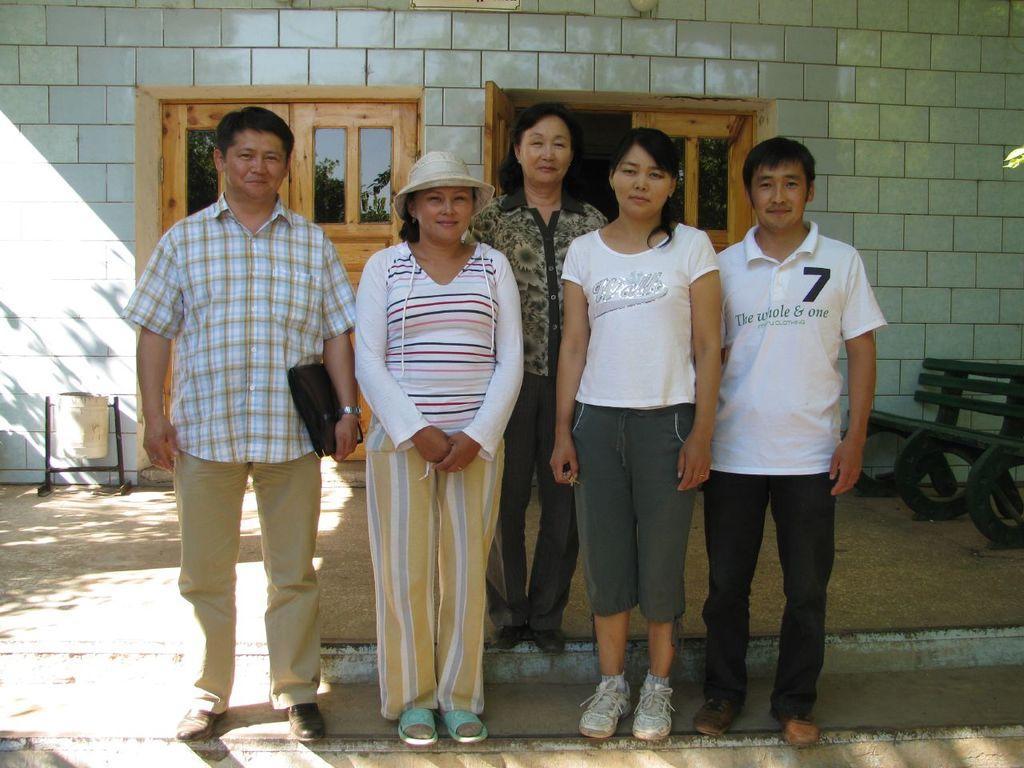Describe this image in one or two sentences. In the image in the center we can see few people were standing and they were smiling,which we can see on their faces. In the background there is a wall,building,window,door,dustbin,bench,staircase etc. 